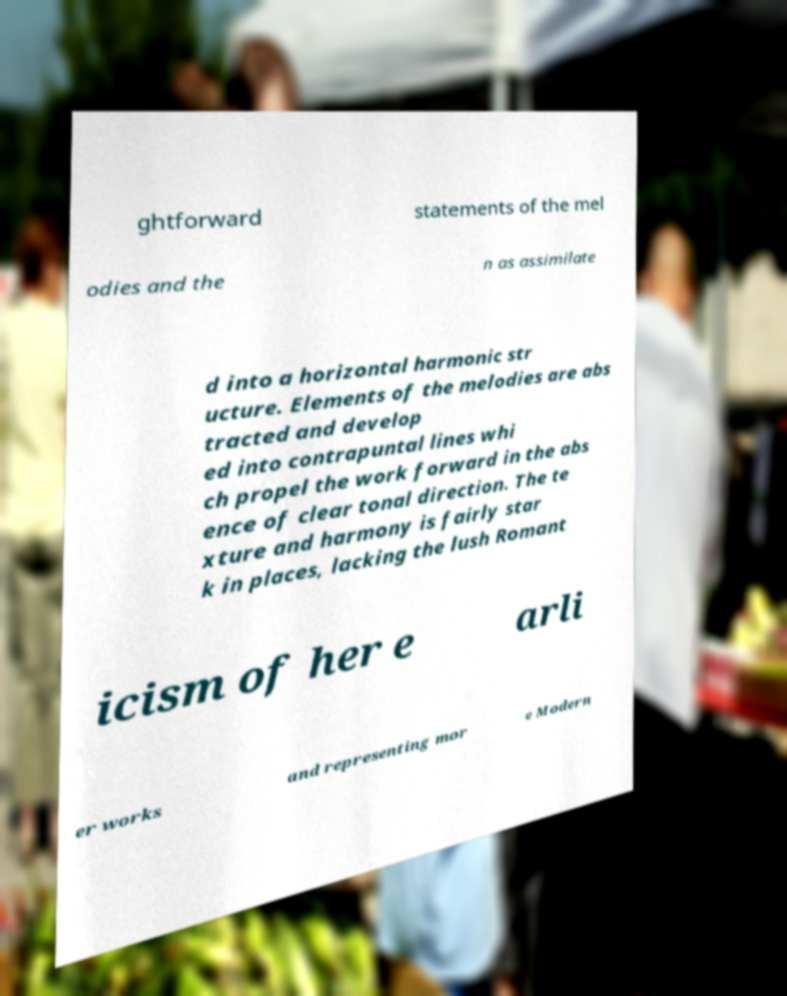Please read and relay the text visible in this image. What does it say? ghtforward statements of the mel odies and the n as assimilate d into a horizontal harmonic str ucture. Elements of the melodies are abs tracted and develop ed into contrapuntal lines whi ch propel the work forward in the abs ence of clear tonal direction. The te xture and harmony is fairly star k in places, lacking the lush Romant icism of her e arli er works and representing mor e Modern 